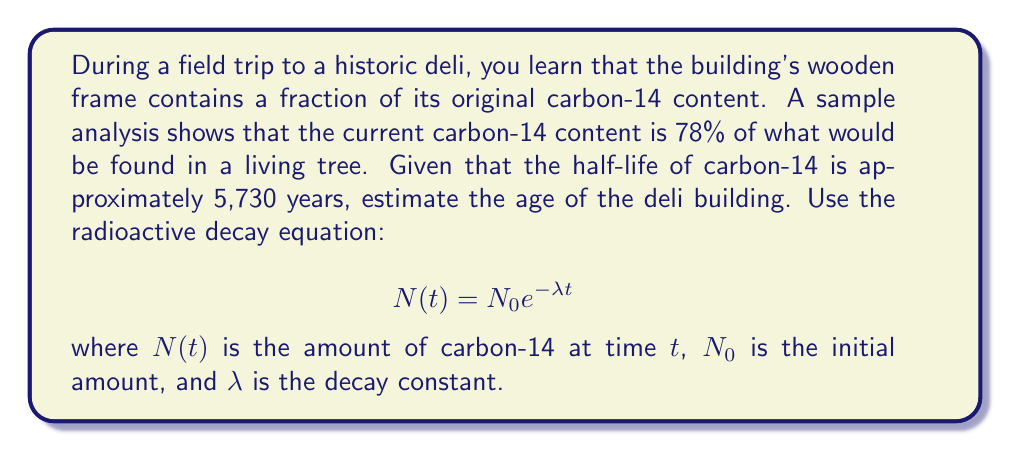Give your solution to this math problem. To solve this problem, we'll follow these steps:

1) First, we need to find the decay constant $\lambda$. We know that the half-life $t_{1/2}$ is 5,730 years. The relationship between $\lambda$ and $t_{1/2}$ is:

   $$\lambda = \frac{\ln(2)}{t_{1/2}} = \frac{\ln(2)}{5730} \approx 1.21 \times 10^{-4} \text{ years}^{-1}$$

2) Now, we can use the radioactive decay equation. We know that the current amount is 78% of the original, so:

   $$\frac{N(t)}{N_0} = 0.78 = e^{-\lambda t}$$

3) Taking the natural logarithm of both sides:

   $$\ln(0.78) = -\lambda t$$

4) Solving for $t$:

   $$t = -\frac{\ln(0.78)}{\lambda} = -\frac{\ln(0.78)}{1.21 \times 10^{-4}} \approx 2052.8 \text{ years}$$

Therefore, the estimated age of the deli building is approximately 2,053 years.
Answer: The estimated age of the deli building is approximately 2,053 years. 